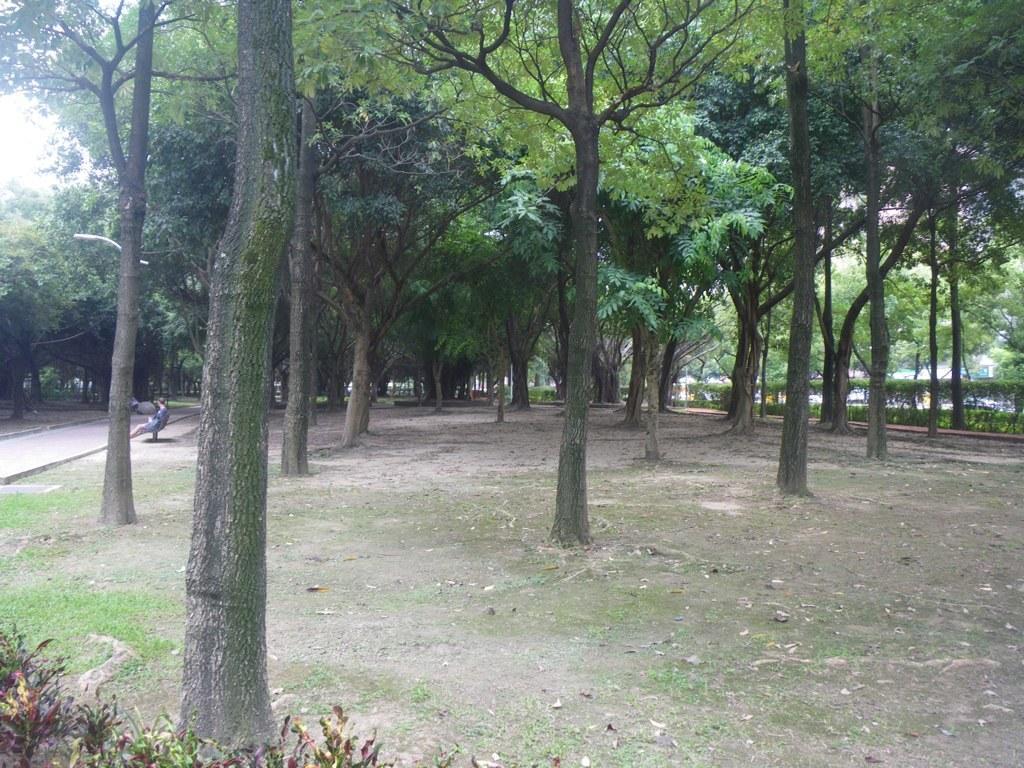In one or two sentences, can you explain what this image depicts? I think this picture was taken in the park. These are the trees with branches and leaves. I can see the small bushes. Here is a person sitting on the bench. This is the pathway. 